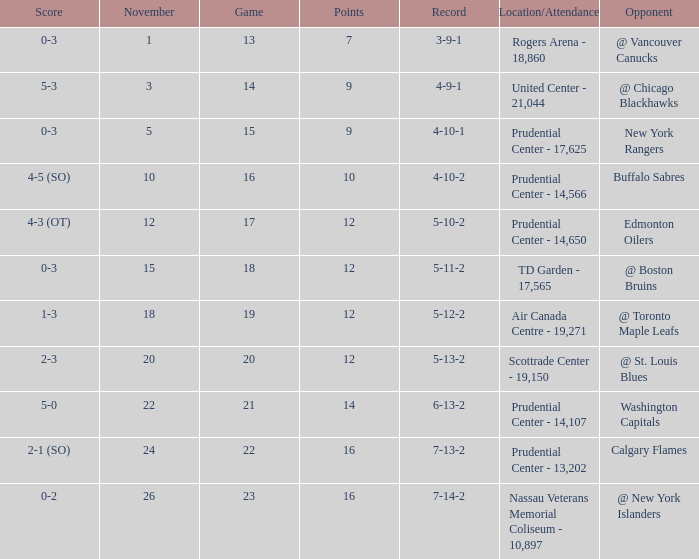What is the record for score 1-3? 5-12-2. 